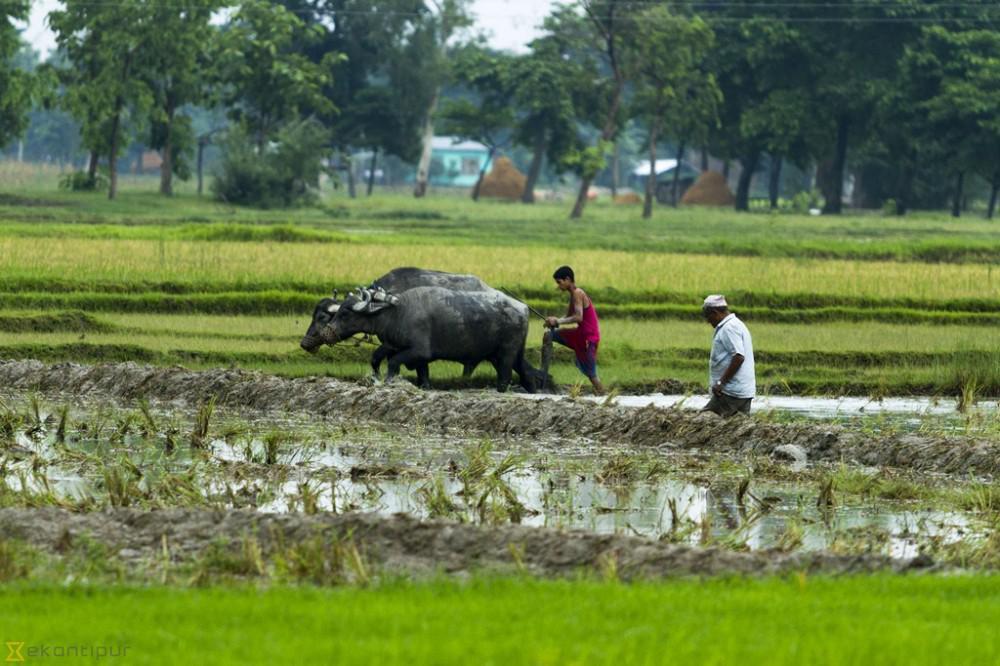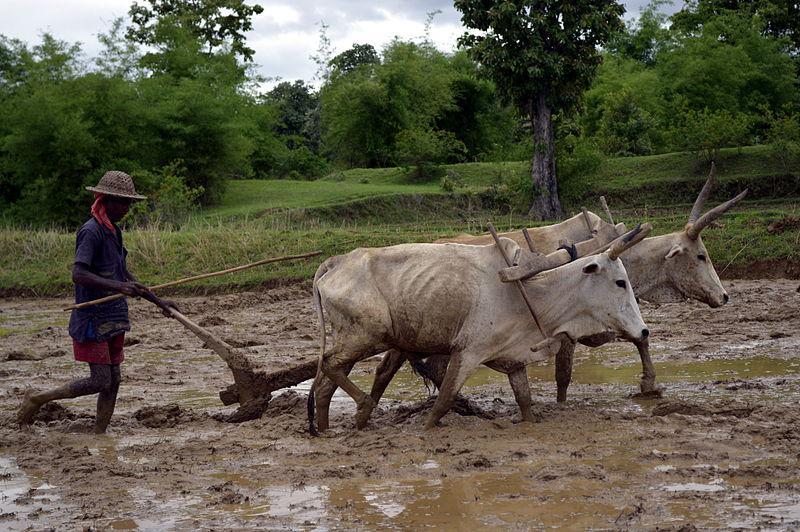The first image is the image on the left, the second image is the image on the right. Analyze the images presented: Is the assertion "At least one image shows a team of two oxen pulling a plow with a man behind it." valid? Answer yes or no. Yes. The first image is the image on the left, the second image is the image on the right. Assess this claim about the two images: "There is no more than one water buffalo in the right image.". Correct or not? Answer yes or no. No. 